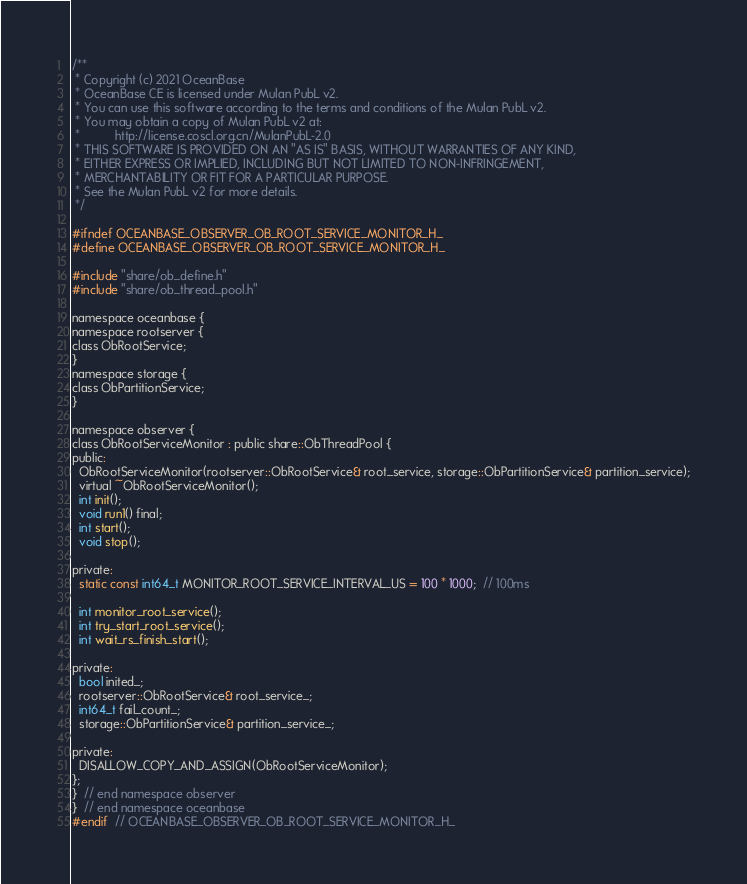<code> <loc_0><loc_0><loc_500><loc_500><_C_>/**
 * Copyright (c) 2021 OceanBase
 * OceanBase CE is licensed under Mulan PubL v2.
 * You can use this software according to the terms and conditions of the Mulan PubL v2.
 * You may obtain a copy of Mulan PubL v2 at:
 *          http://license.coscl.org.cn/MulanPubL-2.0
 * THIS SOFTWARE IS PROVIDED ON AN "AS IS" BASIS, WITHOUT WARRANTIES OF ANY KIND,
 * EITHER EXPRESS OR IMPLIED, INCLUDING BUT NOT LIMITED TO NON-INFRINGEMENT,
 * MERCHANTABILITY OR FIT FOR A PARTICULAR PURPOSE.
 * See the Mulan PubL v2 for more details.
 */

#ifndef OCEANBASE_OBSERVER_OB_ROOT_SERVICE_MONITOR_H_
#define OCEANBASE_OBSERVER_OB_ROOT_SERVICE_MONITOR_H_

#include "share/ob_define.h"
#include "share/ob_thread_pool.h"

namespace oceanbase {
namespace rootserver {
class ObRootService;
}
namespace storage {
class ObPartitionService;
}

namespace observer {
class ObRootServiceMonitor : public share::ObThreadPool {
public:
  ObRootServiceMonitor(rootserver::ObRootService& root_service, storage::ObPartitionService& partition_service);
  virtual ~ObRootServiceMonitor();
  int init();
  void run1() final;
  int start();
  void stop();

private:
  static const int64_t MONITOR_ROOT_SERVICE_INTERVAL_US = 100 * 1000;  // 100ms

  int monitor_root_service();
  int try_start_root_service();
  int wait_rs_finish_start();

private:
  bool inited_;
  rootserver::ObRootService& root_service_;
  int64_t fail_count_;
  storage::ObPartitionService& partition_service_;

private:
  DISALLOW_COPY_AND_ASSIGN(ObRootServiceMonitor);
};
}  // end namespace observer
}  // end namespace oceanbase
#endif  // OCEANBASE_OBSERVER_OB_ROOT_SERVICE_MONITOR_H_
</code> 